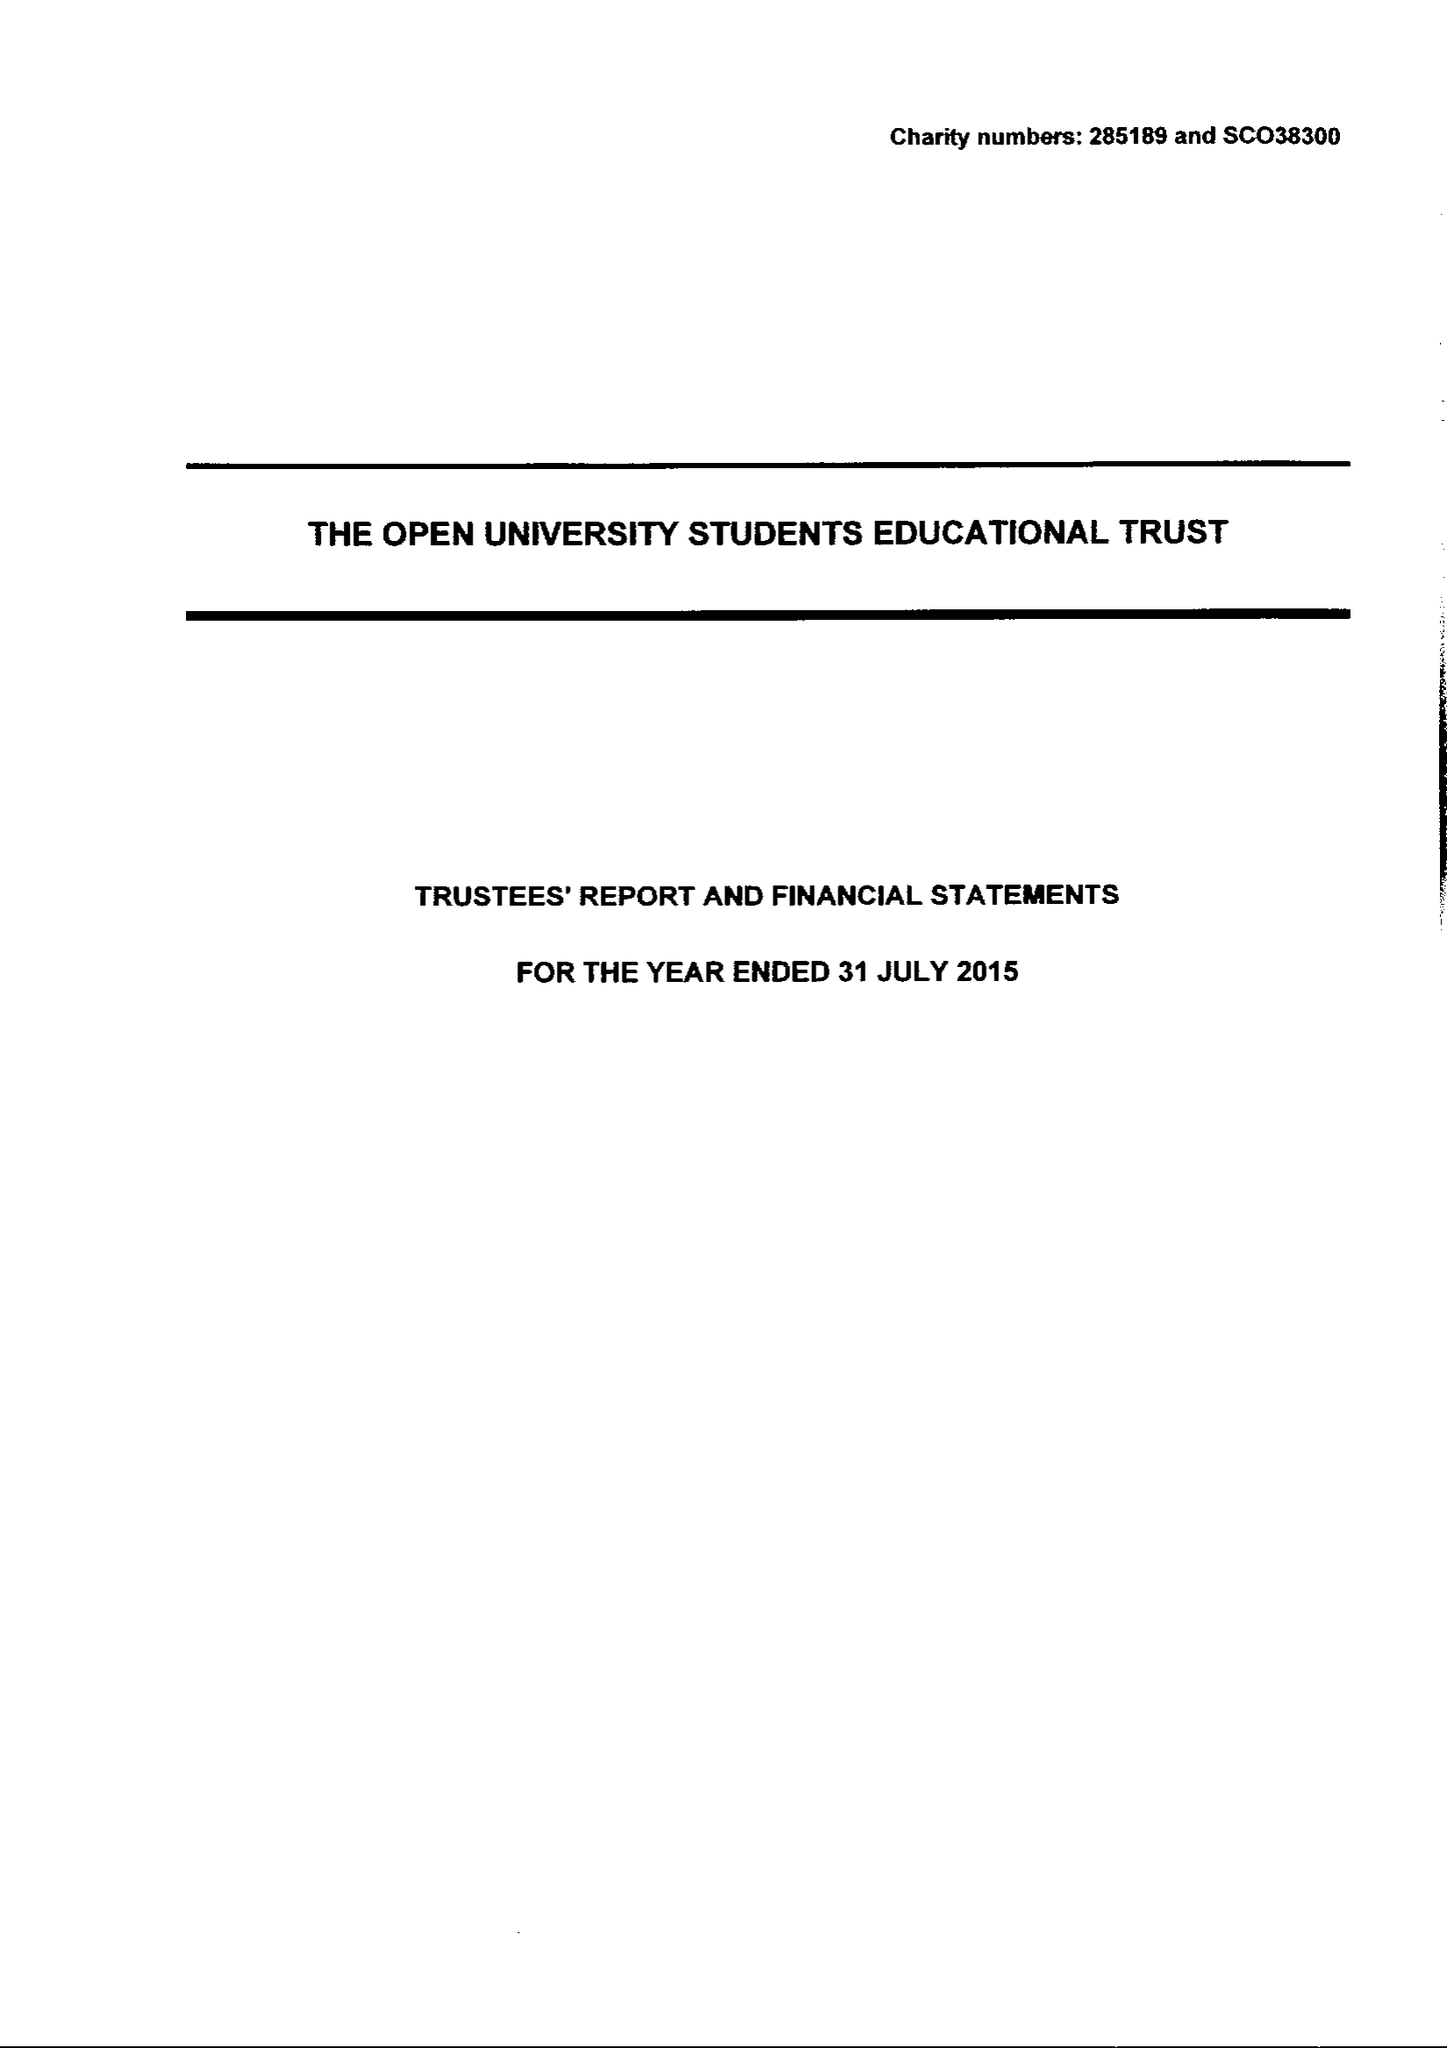What is the value for the address__street_line?
Answer the question using a single word or phrase. PO BOX 397 